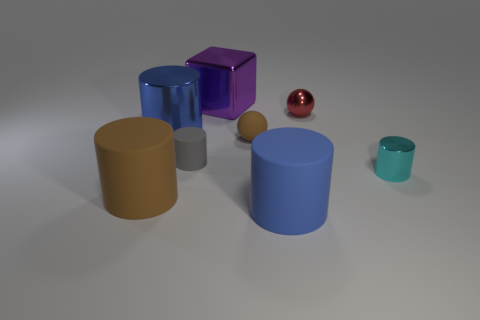Subtract all gray cylinders. How many cylinders are left? 4 Subtract all brown cylinders. How many cylinders are left? 4 Subtract all yellow cylinders. Subtract all blue cubes. How many cylinders are left? 5 Add 1 red cylinders. How many objects exist? 9 Subtract all blocks. How many objects are left? 7 Add 7 small gray metal objects. How many small gray metal objects exist? 7 Subtract 1 brown spheres. How many objects are left? 7 Subtract all brown rubber cylinders. Subtract all gray rubber objects. How many objects are left? 6 Add 2 big blue metal things. How many big blue metal things are left? 3 